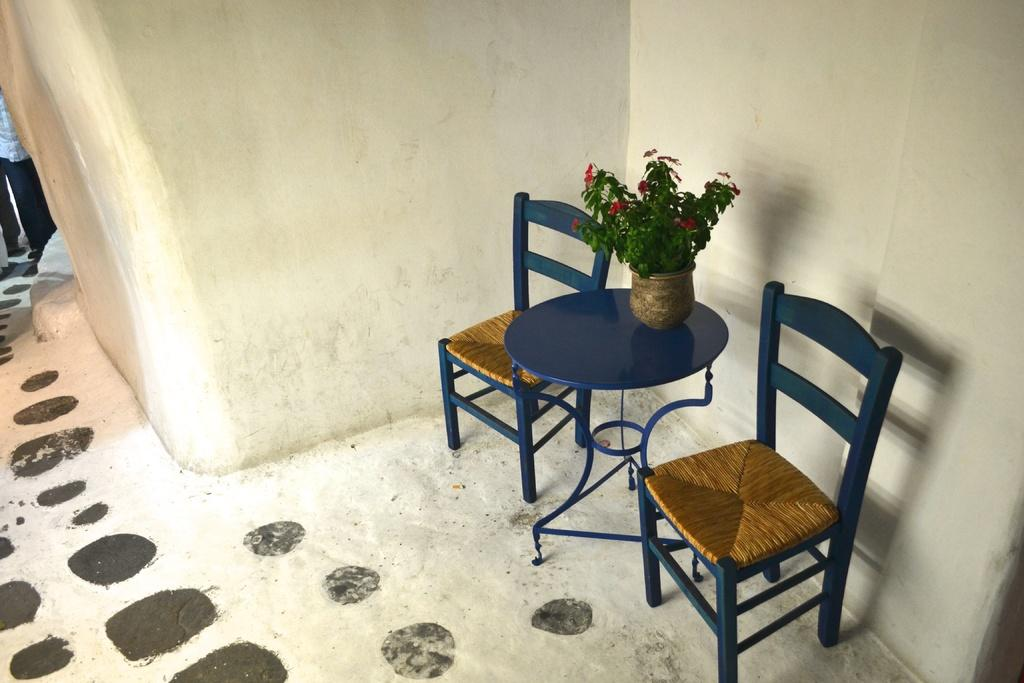How many chairs are visible on the floor in the image? There are two chairs on the floor in the image. What other piece of furniture is present in the image? There is a table in the image. What is placed on the table? There is a flower vase on the table. What is the background of the image? There is a wall in the image. What type of cup is being used to support the roof in the image? There is no roof or cup present in the image. What type of support is the flower vase using to stay upright in the image? The flower vase is placed on the table, and it does not require any additional support to stay upright. 